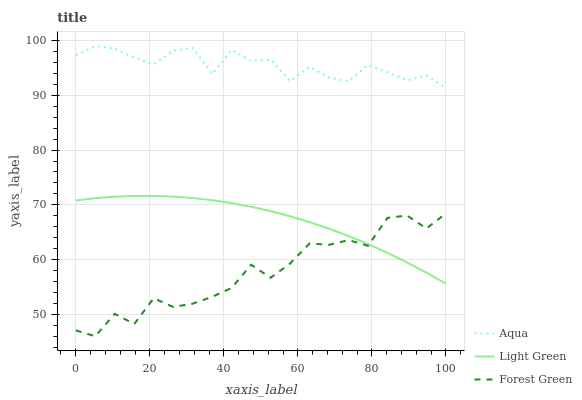Does Forest Green have the minimum area under the curve?
Answer yes or no. Yes. Does Aqua have the maximum area under the curve?
Answer yes or no. Yes. Does Light Green have the minimum area under the curve?
Answer yes or no. No. Does Light Green have the maximum area under the curve?
Answer yes or no. No. Is Light Green the smoothest?
Answer yes or no. Yes. Is Forest Green the roughest?
Answer yes or no. Yes. Is Aqua the smoothest?
Answer yes or no. No. Is Aqua the roughest?
Answer yes or no. No. Does Forest Green have the lowest value?
Answer yes or no. Yes. Does Light Green have the lowest value?
Answer yes or no. No. Does Aqua have the highest value?
Answer yes or no. Yes. Does Light Green have the highest value?
Answer yes or no. No. Is Forest Green less than Aqua?
Answer yes or no. Yes. Is Aqua greater than Light Green?
Answer yes or no. Yes. Does Forest Green intersect Light Green?
Answer yes or no. Yes. Is Forest Green less than Light Green?
Answer yes or no. No. Is Forest Green greater than Light Green?
Answer yes or no. No. Does Forest Green intersect Aqua?
Answer yes or no. No. 